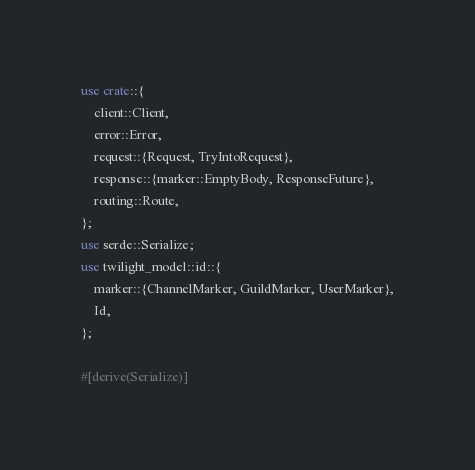<code> <loc_0><loc_0><loc_500><loc_500><_Rust_>use crate::{
    client::Client,
    error::Error,
    request::{Request, TryIntoRequest},
    response::{marker::EmptyBody, ResponseFuture},
    routing::Route,
};
use serde::Serialize;
use twilight_model::id::{
    marker::{ChannelMarker, GuildMarker, UserMarker},
    Id,
};

#[derive(Serialize)]</code> 